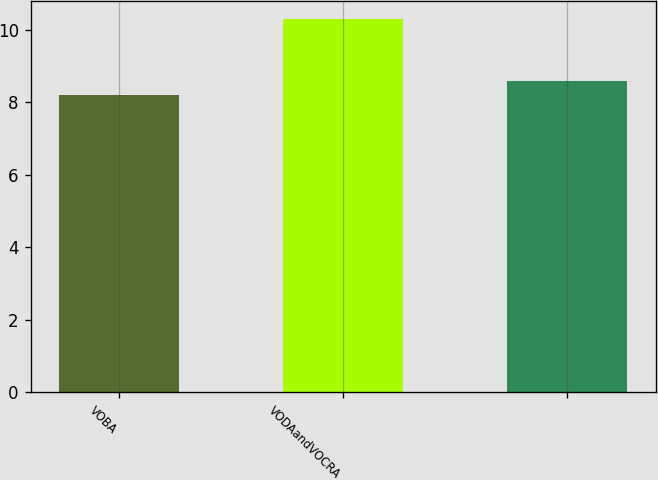Convert chart to OTSL. <chart><loc_0><loc_0><loc_500><loc_500><bar_chart><fcel>VOBA<fcel>VODAandVOCRA<fcel>Unnamed: 2<nl><fcel>8.2<fcel>10.3<fcel>8.6<nl></chart> 